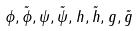<formula> <loc_0><loc_0><loc_500><loc_500>\phi , \tilde { \phi } , \psi , \tilde { \psi } , h , \tilde { h } , g , \tilde { g }</formula> 